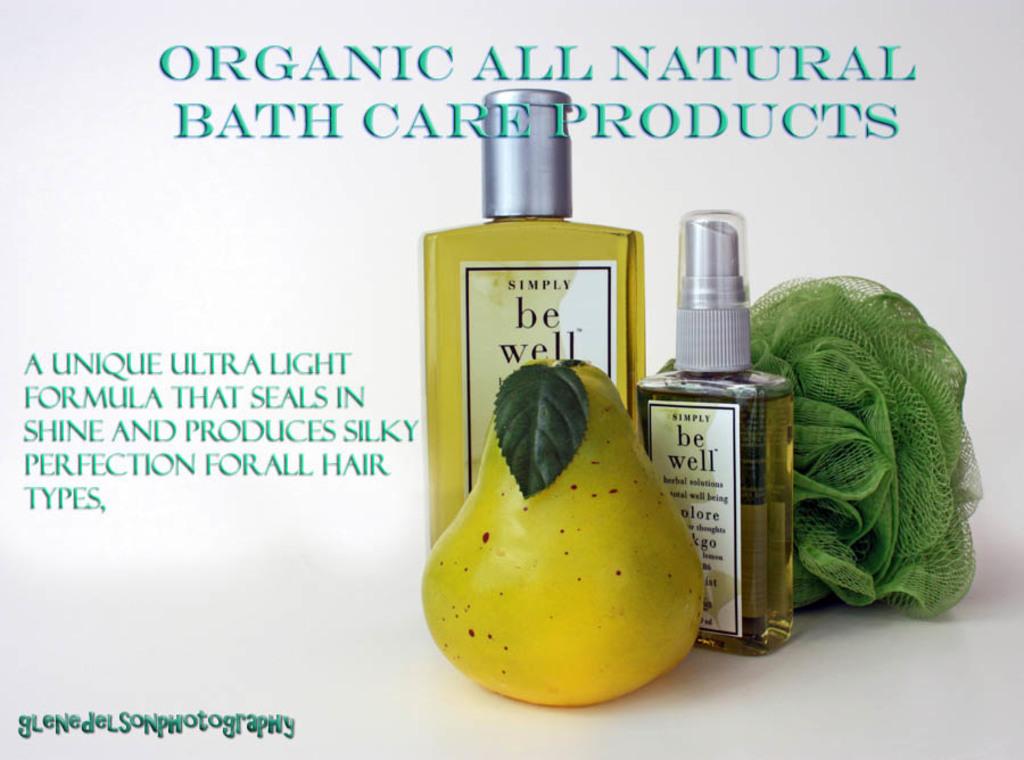Will this body soap leave me with smooth skin?
Offer a very short reply. No. 